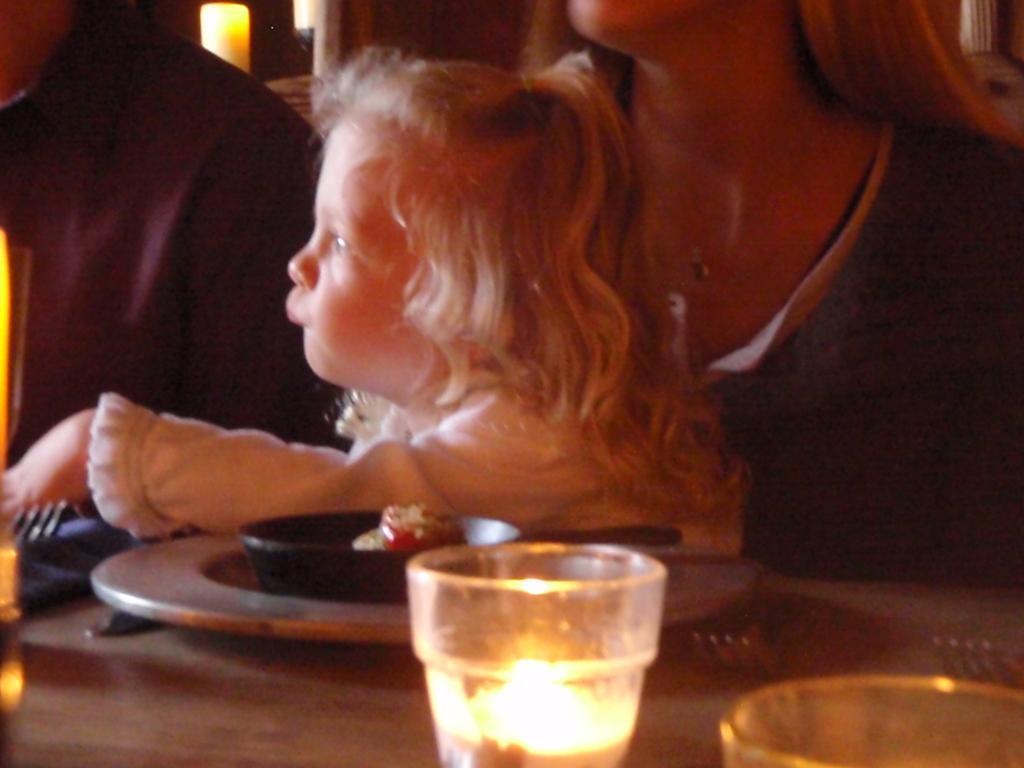In one or two sentences, can you explain what this image depicts? In this picture we can see three persons and in front of them on table we can see a plate, forks, glasses, bowl with a food in it and in the background we can see a candle. 